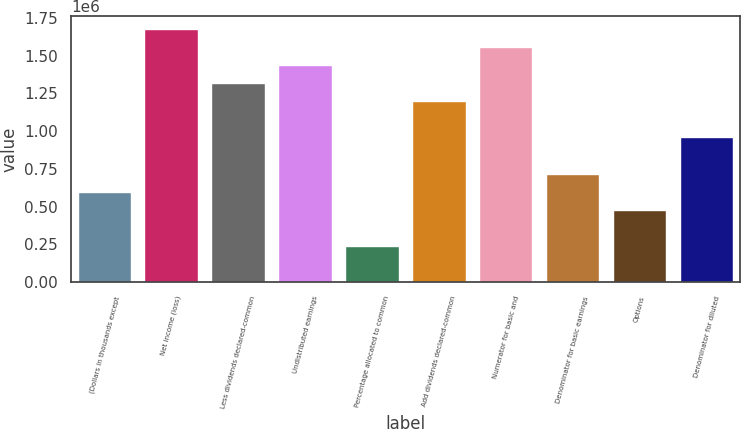Convert chart. <chart><loc_0><loc_0><loc_500><loc_500><bar_chart><fcel>(Dollars in thousands except<fcel>Net income (loss)<fcel>Less dividends declared-common<fcel>Undistributed earnings<fcel>Percentage allocated to common<fcel>Add dividends declared-common<fcel>Numerator for basic and<fcel>Denominator for basic earnings<fcel>Options<fcel>Denominator for diluted<nl><fcel>599591<fcel>1.67881e+06<fcel>1.31907e+06<fcel>1.43898e+06<fcel>239852<fcel>1.19916e+06<fcel>1.5589e+06<fcel>719504<fcel>479678<fcel>959330<nl></chart> 